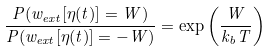<formula> <loc_0><loc_0><loc_500><loc_500>\frac { P ( w _ { e x t } [ \eta ( t ) ] = W ) } { P ( w _ { e x t } [ \eta ( t ) ] = - W ) } = \exp \left ( \frac { W } { k _ { b } T } \right )</formula> 